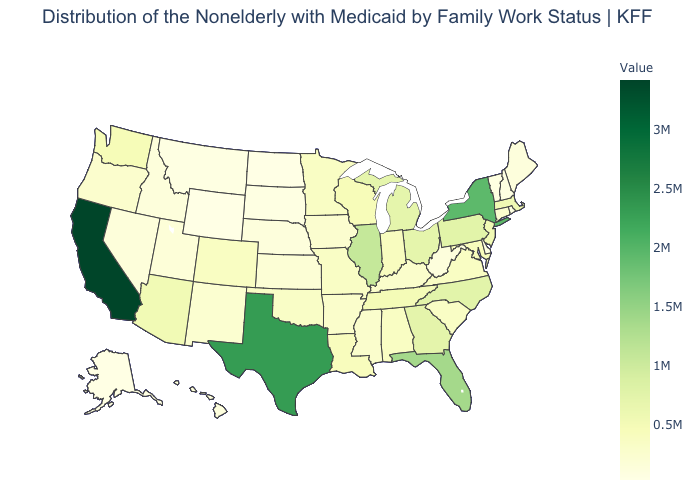Among the states that border Maine , which have the highest value?
Quick response, please. New Hampshire. Does the map have missing data?
Give a very brief answer. No. Does Texas have the highest value in the South?
Short answer required. Yes. Does Wisconsin have the highest value in the MidWest?
Be succinct. No. Among the states that border Georgia , does Florida have the highest value?
Short answer required. Yes. Is the legend a continuous bar?
Write a very short answer. Yes. 